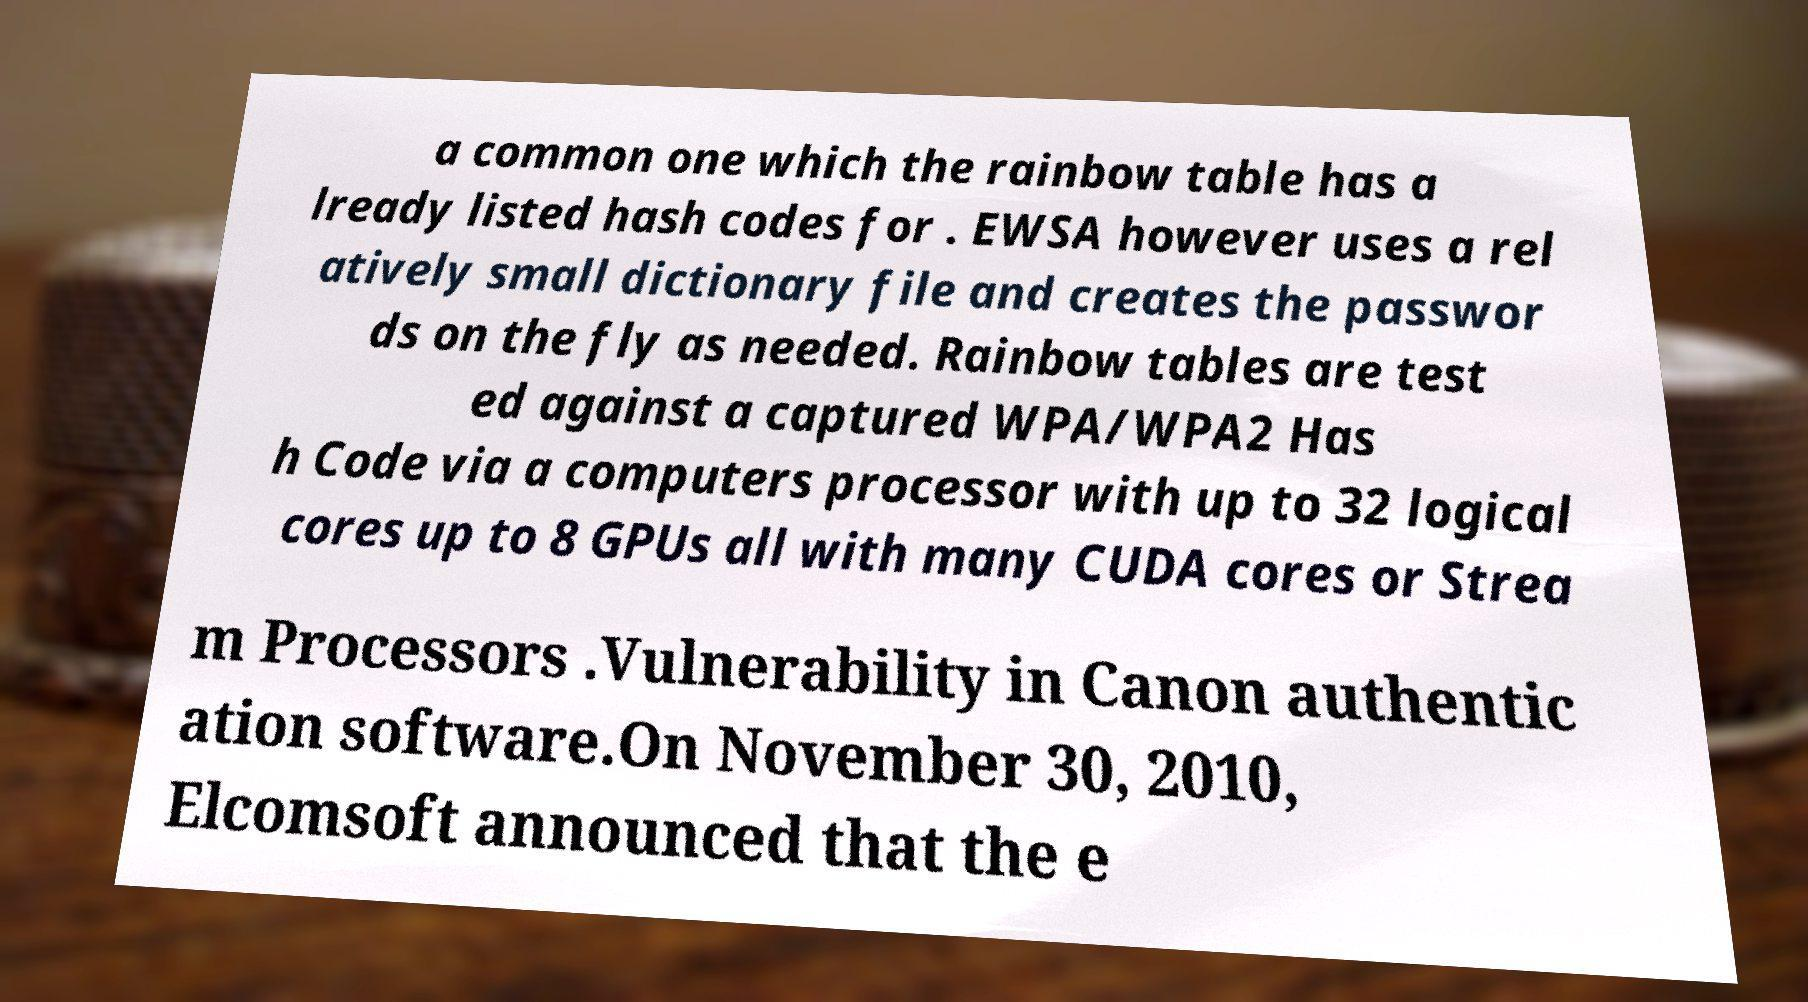I need the written content from this picture converted into text. Can you do that? a common one which the rainbow table has a lready listed hash codes for . EWSA however uses a rel atively small dictionary file and creates the passwor ds on the fly as needed. Rainbow tables are test ed against a captured WPA/WPA2 Has h Code via a computers processor with up to 32 logical cores up to 8 GPUs all with many CUDA cores or Strea m Processors .Vulnerability in Canon authentic ation software.On November 30, 2010, Elcomsoft announced that the e 